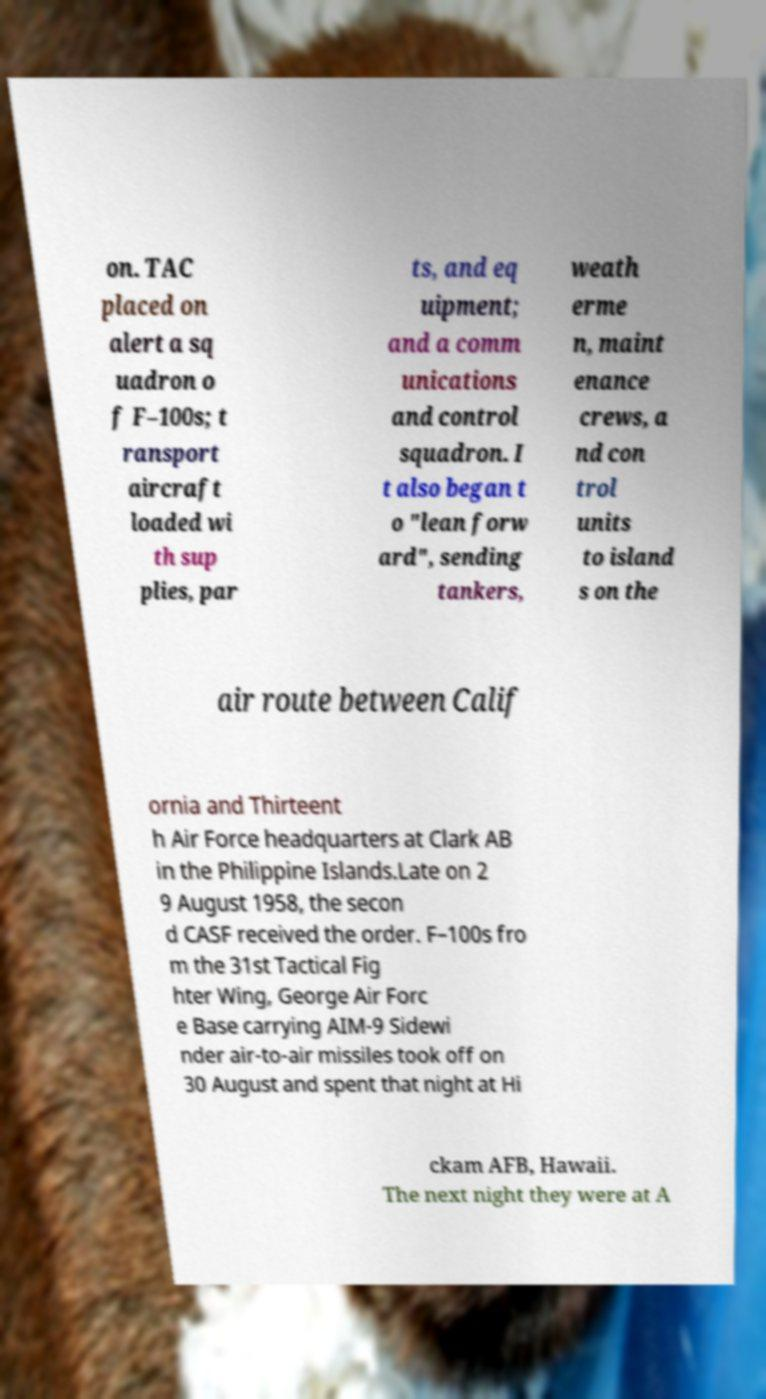Please read and relay the text visible in this image. What does it say? on. TAC placed on alert a sq uadron o f F–100s; t ransport aircraft loaded wi th sup plies, par ts, and eq uipment; and a comm unications and control squadron. I t also began t o "lean forw ard", sending tankers, weath erme n, maint enance crews, a nd con trol units to island s on the air route between Calif ornia and Thirteent h Air Force headquarters at Clark AB in the Philippine Islands.Late on 2 9 August 1958, the secon d CASF received the order. F–100s fro m the 31st Tactical Fig hter Wing, George Air Forc e Base carrying AIM-9 Sidewi nder air-to-air missiles took off on 30 August and spent that night at Hi ckam AFB, Hawaii. The next night they were at A 